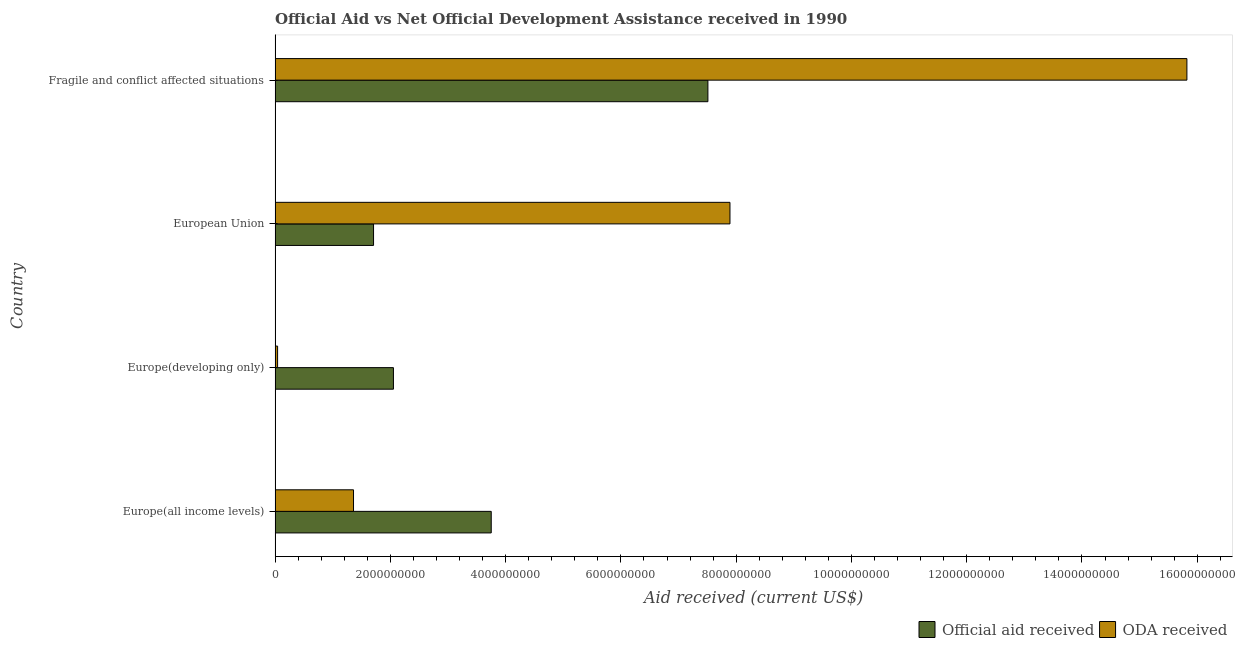How many bars are there on the 1st tick from the top?
Ensure brevity in your answer.  2. What is the label of the 4th group of bars from the top?
Your answer should be very brief. Europe(all income levels). In how many cases, is the number of bars for a given country not equal to the number of legend labels?
Your answer should be very brief. 0. What is the official aid received in European Union?
Keep it short and to the point. 1.71e+09. Across all countries, what is the maximum oda received?
Your answer should be compact. 1.58e+1. Across all countries, what is the minimum official aid received?
Your response must be concise. 1.71e+09. In which country was the official aid received maximum?
Your answer should be very brief. Fragile and conflict affected situations. In which country was the official aid received minimum?
Your answer should be very brief. European Union. What is the total oda received in the graph?
Make the answer very short. 2.51e+1. What is the difference between the oda received in Europe(all income levels) and that in European Union?
Offer a very short reply. -6.53e+09. What is the difference between the oda received in Europe(developing only) and the official aid received in Europe(all income levels)?
Keep it short and to the point. -3.71e+09. What is the average official aid received per country?
Provide a short and direct response. 3.76e+09. What is the difference between the oda received and official aid received in Fragile and conflict affected situations?
Provide a short and direct response. 8.31e+09. What is the ratio of the official aid received in Europe(all income levels) to that in European Union?
Offer a terse response. 2.19. Is the oda received in Europe(developing only) less than that in European Union?
Provide a short and direct response. Yes. What is the difference between the highest and the second highest oda received?
Keep it short and to the point. 7.93e+09. What is the difference between the highest and the lowest oda received?
Give a very brief answer. 1.58e+1. In how many countries, is the official aid received greater than the average official aid received taken over all countries?
Provide a succinct answer. 1. What does the 2nd bar from the top in Fragile and conflict affected situations represents?
Make the answer very short. Official aid received. What does the 1st bar from the bottom in Fragile and conflict affected situations represents?
Your answer should be very brief. Official aid received. How many bars are there?
Your answer should be very brief. 8. What is the difference between two consecutive major ticks on the X-axis?
Your response must be concise. 2.00e+09. Where does the legend appear in the graph?
Ensure brevity in your answer.  Bottom right. How many legend labels are there?
Provide a short and direct response. 2. What is the title of the graph?
Offer a very short reply. Official Aid vs Net Official Development Assistance received in 1990 . Does "Investment in Telecom" appear as one of the legend labels in the graph?
Your response must be concise. No. What is the label or title of the X-axis?
Your answer should be compact. Aid received (current US$). What is the Aid received (current US$) of Official aid received in Europe(all income levels)?
Keep it short and to the point. 3.75e+09. What is the Aid received (current US$) of ODA received in Europe(all income levels)?
Make the answer very short. 1.36e+09. What is the Aid received (current US$) in Official aid received in Europe(developing only)?
Keep it short and to the point. 2.05e+09. What is the Aid received (current US$) in ODA received in Europe(developing only)?
Your answer should be compact. 4.37e+07. What is the Aid received (current US$) in Official aid received in European Union?
Make the answer very short. 1.71e+09. What is the Aid received (current US$) of ODA received in European Union?
Ensure brevity in your answer.  7.89e+09. What is the Aid received (current US$) in Official aid received in Fragile and conflict affected situations?
Make the answer very short. 7.51e+09. What is the Aid received (current US$) of ODA received in Fragile and conflict affected situations?
Ensure brevity in your answer.  1.58e+1. Across all countries, what is the maximum Aid received (current US$) of Official aid received?
Ensure brevity in your answer.  7.51e+09. Across all countries, what is the maximum Aid received (current US$) in ODA received?
Your answer should be very brief. 1.58e+1. Across all countries, what is the minimum Aid received (current US$) of Official aid received?
Provide a short and direct response. 1.71e+09. Across all countries, what is the minimum Aid received (current US$) of ODA received?
Keep it short and to the point. 4.37e+07. What is the total Aid received (current US$) in Official aid received in the graph?
Make the answer very short. 1.50e+1. What is the total Aid received (current US$) of ODA received in the graph?
Your response must be concise. 2.51e+1. What is the difference between the Aid received (current US$) in Official aid received in Europe(all income levels) and that in Europe(developing only)?
Keep it short and to the point. 1.70e+09. What is the difference between the Aid received (current US$) in ODA received in Europe(all income levels) and that in Europe(developing only)?
Keep it short and to the point. 1.32e+09. What is the difference between the Aid received (current US$) in Official aid received in Europe(all income levels) and that in European Union?
Your answer should be compact. 2.04e+09. What is the difference between the Aid received (current US$) in ODA received in Europe(all income levels) and that in European Union?
Ensure brevity in your answer.  -6.53e+09. What is the difference between the Aid received (current US$) of Official aid received in Europe(all income levels) and that in Fragile and conflict affected situations?
Provide a short and direct response. -3.76e+09. What is the difference between the Aid received (current US$) in ODA received in Europe(all income levels) and that in Fragile and conflict affected situations?
Your answer should be very brief. -1.45e+1. What is the difference between the Aid received (current US$) of Official aid received in Europe(developing only) and that in European Union?
Make the answer very short. 3.45e+08. What is the difference between the Aid received (current US$) in ODA received in Europe(developing only) and that in European Union?
Offer a very short reply. -7.85e+09. What is the difference between the Aid received (current US$) in Official aid received in Europe(developing only) and that in Fragile and conflict affected situations?
Provide a succinct answer. -5.46e+09. What is the difference between the Aid received (current US$) of ODA received in Europe(developing only) and that in Fragile and conflict affected situations?
Offer a very short reply. -1.58e+1. What is the difference between the Aid received (current US$) of Official aid received in European Union and that in Fragile and conflict affected situations?
Keep it short and to the point. -5.80e+09. What is the difference between the Aid received (current US$) in ODA received in European Union and that in Fragile and conflict affected situations?
Offer a very short reply. -7.93e+09. What is the difference between the Aid received (current US$) in Official aid received in Europe(all income levels) and the Aid received (current US$) in ODA received in Europe(developing only)?
Keep it short and to the point. 3.71e+09. What is the difference between the Aid received (current US$) of Official aid received in Europe(all income levels) and the Aid received (current US$) of ODA received in European Union?
Keep it short and to the point. -4.14e+09. What is the difference between the Aid received (current US$) of Official aid received in Europe(all income levels) and the Aid received (current US$) of ODA received in Fragile and conflict affected situations?
Offer a very short reply. -1.21e+1. What is the difference between the Aid received (current US$) in Official aid received in Europe(developing only) and the Aid received (current US$) in ODA received in European Union?
Offer a very short reply. -5.84e+09. What is the difference between the Aid received (current US$) of Official aid received in Europe(developing only) and the Aid received (current US$) of ODA received in Fragile and conflict affected situations?
Offer a very short reply. -1.38e+1. What is the difference between the Aid received (current US$) of Official aid received in European Union and the Aid received (current US$) of ODA received in Fragile and conflict affected situations?
Ensure brevity in your answer.  -1.41e+1. What is the average Aid received (current US$) of Official aid received per country?
Provide a succinct answer. 3.76e+09. What is the average Aid received (current US$) in ODA received per country?
Ensure brevity in your answer.  6.28e+09. What is the difference between the Aid received (current US$) of Official aid received and Aid received (current US$) of ODA received in Europe(all income levels)?
Give a very brief answer. 2.39e+09. What is the difference between the Aid received (current US$) of Official aid received and Aid received (current US$) of ODA received in Europe(developing only)?
Give a very brief answer. 2.01e+09. What is the difference between the Aid received (current US$) in Official aid received and Aid received (current US$) in ODA received in European Union?
Make the answer very short. -6.18e+09. What is the difference between the Aid received (current US$) in Official aid received and Aid received (current US$) in ODA received in Fragile and conflict affected situations?
Your answer should be very brief. -8.31e+09. What is the ratio of the Aid received (current US$) in Official aid received in Europe(all income levels) to that in Europe(developing only)?
Your answer should be very brief. 1.83. What is the ratio of the Aid received (current US$) in ODA received in Europe(all income levels) to that in Europe(developing only)?
Provide a short and direct response. 31.11. What is the ratio of the Aid received (current US$) of Official aid received in Europe(all income levels) to that in European Union?
Your answer should be very brief. 2.2. What is the ratio of the Aid received (current US$) in ODA received in Europe(all income levels) to that in European Union?
Offer a terse response. 0.17. What is the ratio of the Aid received (current US$) in Official aid received in Europe(all income levels) to that in Fragile and conflict affected situations?
Your answer should be very brief. 0.5. What is the ratio of the Aid received (current US$) in ODA received in Europe(all income levels) to that in Fragile and conflict affected situations?
Keep it short and to the point. 0.09. What is the ratio of the Aid received (current US$) in Official aid received in Europe(developing only) to that in European Union?
Give a very brief answer. 1.2. What is the ratio of the Aid received (current US$) in ODA received in Europe(developing only) to that in European Union?
Offer a terse response. 0.01. What is the ratio of the Aid received (current US$) in Official aid received in Europe(developing only) to that in Fragile and conflict affected situations?
Ensure brevity in your answer.  0.27. What is the ratio of the Aid received (current US$) in ODA received in Europe(developing only) to that in Fragile and conflict affected situations?
Your answer should be very brief. 0. What is the ratio of the Aid received (current US$) in Official aid received in European Union to that in Fragile and conflict affected situations?
Give a very brief answer. 0.23. What is the ratio of the Aid received (current US$) in ODA received in European Union to that in Fragile and conflict affected situations?
Give a very brief answer. 0.5. What is the difference between the highest and the second highest Aid received (current US$) of Official aid received?
Provide a short and direct response. 3.76e+09. What is the difference between the highest and the second highest Aid received (current US$) in ODA received?
Offer a terse response. 7.93e+09. What is the difference between the highest and the lowest Aid received (current US$) in Official aid received?
Make the answer very short. 5.80e+09. What is the difference between the highest and the lowest Aid received (current US$) in ODA received?
Your answer should be very brief. 1.58e+1. 